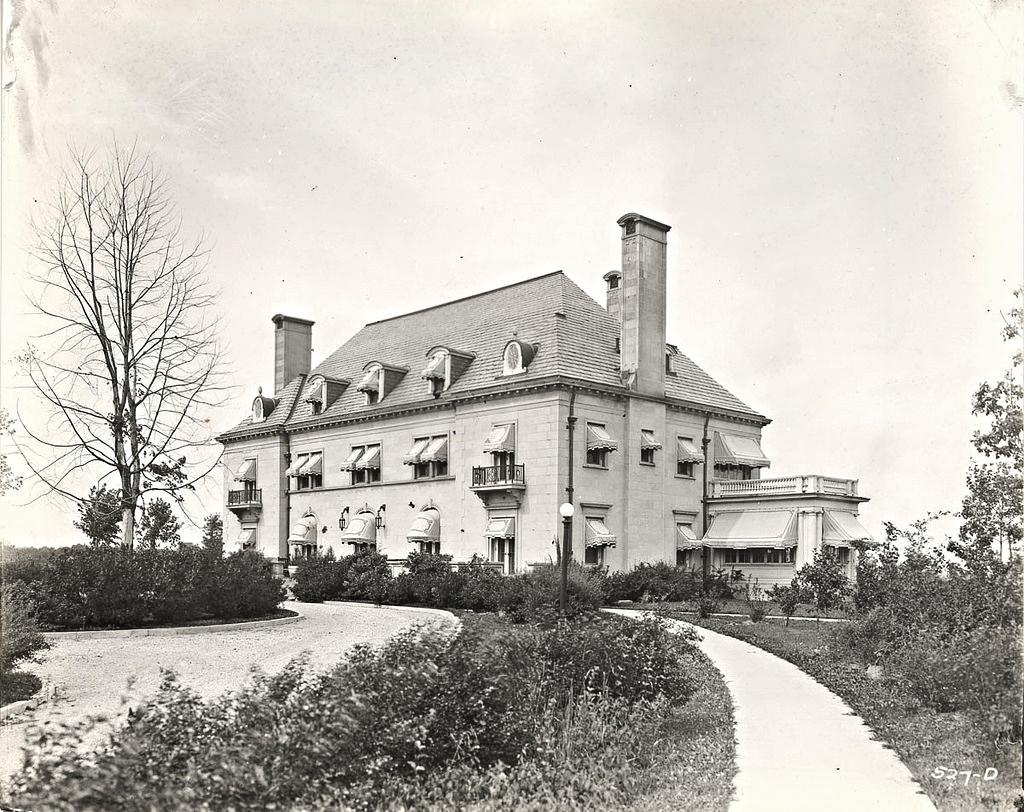In one or two sentences, can you explain what this image depicts? In this image we can see a building and at the foreground of the image there are some trees, plants and way and at the top of the image there is clear sky. 